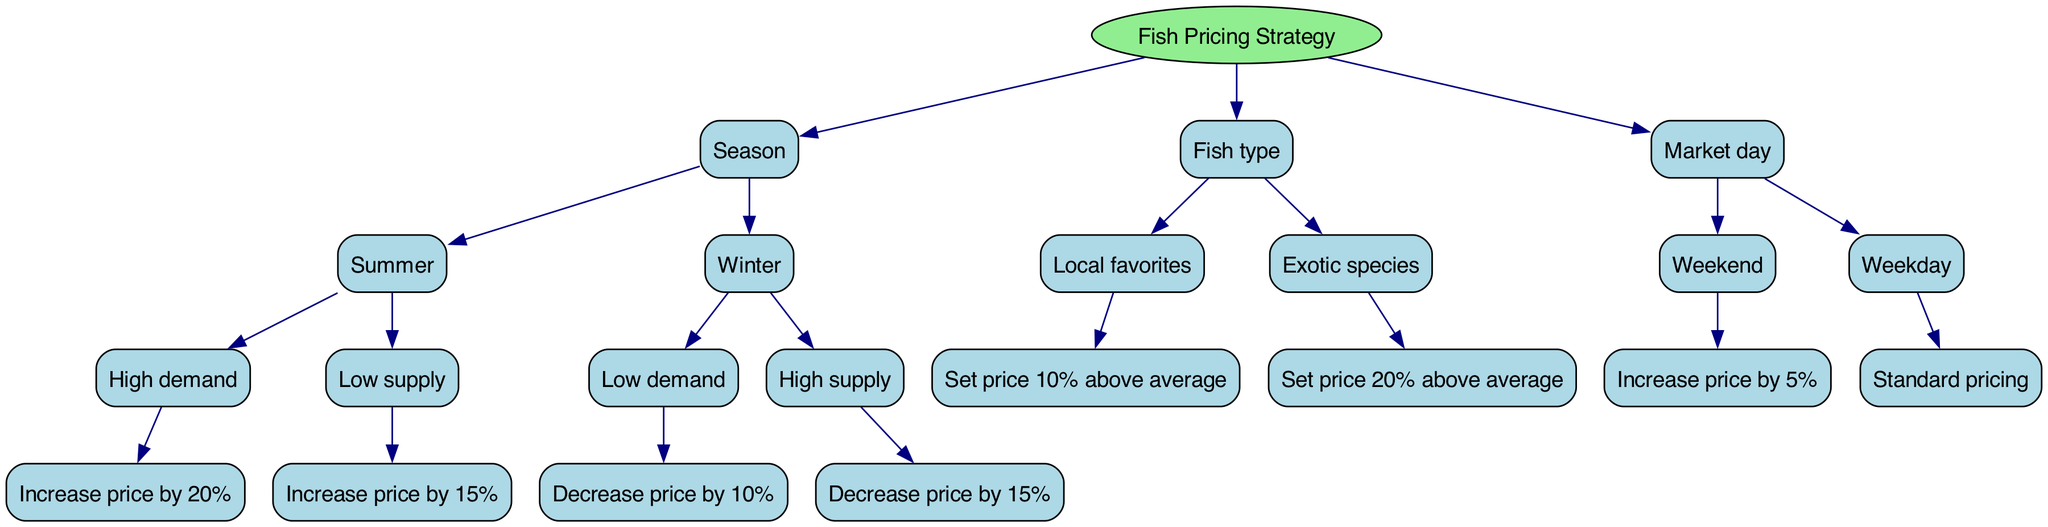What is the root of the decision tree? The root node of the decision tree is "Fish Pricing Strategy," which represents the main topic of the decision-making process.
Answer: Fish Pricing Strategy How many main nodes are there? The diagram contains three main nodes, which are "Season," "Fish type," and "Market day." These represent the main decision factors in pricing strategy.
Answer: 3 What percentage should the price be increased by during high demand in summer? According to the diagram, during high demand in summer, the recommendation is to "Increase price by 20%."
Answer: Increase price by 20% What happens to pricing during low demand in winter? The decision tree indicates that during low demand in winter, the price should be "Decrease price by 10%."
Answer: Decrease price by 10% If it’s a weekend day, what is the pricing change? The diagram states that on a weekend, the recommended action is to "Increase price by 5%," reflecting the higher demand associated with these days.
Answer: Increase price by 5% What price adjustment is suggested for exotic species? For exotic species, the decision tree states to "Set price 20% above average," indicating a premium pricing strategy for rarer fish types.
Answer: Set price 20% above average What is the outcome if both supply is high and demand is low in winter? The tree indicates that if demand is low in winter, the price should "Decrease price by 10%" while if supply is high, the recommendation is to "Decrease price by 15%". Thus, applying the more significant price reduction of 15% would be appropriate here.
Answer: Decrease price by 15% In which season would you increase the price if the supply is low? The decision tree illustrates that if supply is low, during the summer season, the action to take is to "Increase price by 15%."
Answer: Summer How is the pricing affected if a fish type is classified as a local favorite? For local favorites, the decision is to "Set price 10% above average," reflecting a slight premium for locally preferred species.
Answer: Set price 10% above average 